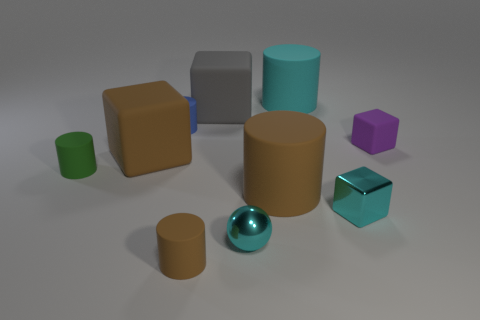How many objects are there in the image and can you describe their colors? There are eight objects in the image. Starting from the left, there is a small green cylinder, a medium brown cube, a large gray cube, a small blue sphere, a large brown cylinder, a small purple cube, a large cyan cylinder, and finally a small metallic sphere. 